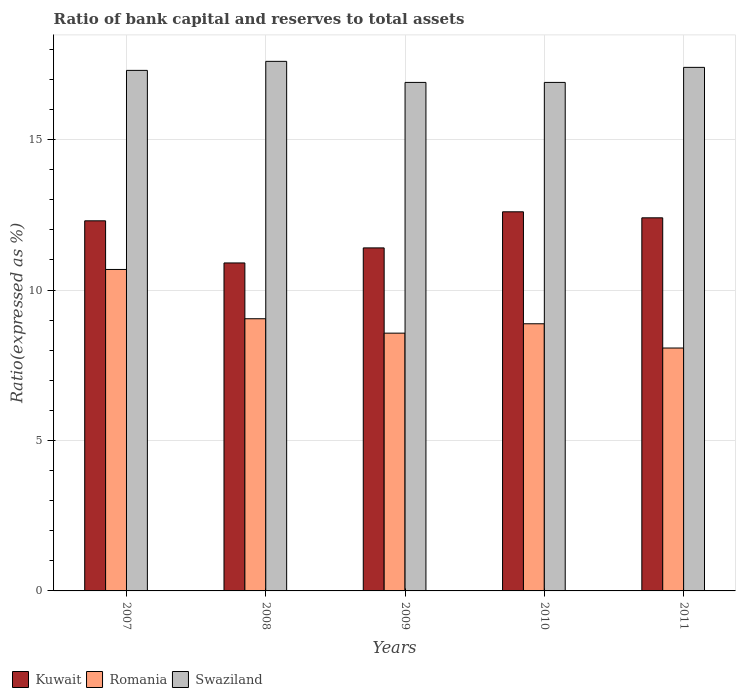Are the number of bars per tick equal to the number of legend labels?
Your answer should be very brief. Yes. Are the number of bars on each tick of the X-axis equal?
Your answer should be very brief. Yes. How many bars are there on the 5th tick from the left?
Provide a short and direct response. 3. How many bars are there on the 3rd tick from the right?
Ensure brevity in your answer.  3. What is the label of the 1st group of bars from the left?
Your answer should be very brief. 2007. What is the total ratio of bank capital and reserves to total assets in Swaziland in the graph?
Keep it short and to the point. 86.1. What is the difference between the ratio of bank capital and reserves to total assets in Swaziland in 2007 and that in 2010?
Make the answer very short. 0.4. What is the average ratio of bank capital and reserves to total assets in Swaziland per year?
Give a very brief answer. 17.22. In the year 2008, what is the difference between the ratio of bank capital and reserves to total assets in Kuwait and ratio of bank capital and reserves to total assets in Romania?
Your response must be concise. 1.85. What is the ratio of the ratio of bank capital and reserves to total assets in Romania in 2008 to that in 2009?
Provide a succinct answer. 1.06. Is the ratio of bank capital and reserves to total assets in Swaziland in 2007 less than that in 2009?
Provide a short and direct response. No. What is the difference between the highest and the second highest ratio of bank capital and reserves to total assets in Swaziland?
Your answer should be very brief. 0.2. What is the difference between the highest and the lowest ratio of bank capital and reserves to total assets in Swaziland?
Offer a terse response. 0.7. In how many years, is the ratio of bank capital and reserves to total assets in Swaziland greater than the average ratio of bank capital and reserves to total assets in Swaziland taken over all years?
Provide a succinct answer. 3. What does the 3rd bar from the left in 2010 represents?
Give a very brief answer. Swaziland. What does the 1st bar from the right in 2008 represents?
Give a very brief answer. Swaziland. Is it the case that in every year, the sum of the ratio of bank capital and reserves to total assets in Kuwait and ratio of bank capital and reserves to total assets in Swaziland is greater than the ratio of bank capital and reserves to total assets in Romania?
Make the answer very short. Yes. How many bars are there?
Your answer should be very brief. 15. Are all the bars in the graph horizontal?
Make the answer very short. No. Does the graph contain any zero values?
Make the answer very short. No. Does the graph contain grids?
Provide a short and direct response. Yes. How many legend labels are there?
Make the answer very short. 3. What is the title of the graph?
Give a very brief answer. Ratio of bank capital and reserves to total assets. What is the label or title of the X-axis?
Your answer should be very brief. Years. What is the label or title of the Y-axis?
Offer a very short reply. Ratio(expressed as %). What is the Ratio(expressed as %) in Romania in 2007?
Your response must be concise. 10.68. What is the Ratio(expressed as %) in Swaziland in 2007?
Give a very brief answer. 17.3. What is the Ratio(expressed as %) in Kuwait in 2008?
Your answer should be compact. 10.9. What is the Ratio(expressed as %) of Romania in 2008?
Your answer should be compact. 9.05. What is the Ratio(expressed as %) in Kuwait in 2009?
Your response must be concise. 11.4. What is the Ratio(expressed as %) of Romania in 2009?
Ensure brevity in your answer.  8.57. What is the Ratio(expressed as %) in Swaziland in 2009?
Your response must be concise. 16.9. What is the Ratio(expressed as %) in Romania in 2010?
Give a very brief answer. 8.88. What is the Ratio(expressed as %) of Swaziland in 2010?
Provide a succinct answer. 16.9. What is the Ratio(expressed as %) of Kuwait in 2011?
Give a very brief answer. 12.4. What is the Ratio(expressed as %) of Romania in 2011?
Provide a short and direct response. 8.07. Across all years, what is the maximum Ratio(expressed as %) in Kuwait?
Give a very brief answer. 12.6. Across all years, what is the maximum Ratio(expressed as %) of Romania?
Your response must be concise. 10.68. Across all years, what is the minimum Ratio(expressed as %) in Kuwait?
Your answer should be very brief. 10.9. Across all years, what is the minimum Ratio(expressed as %) of Romania?
Provide a succinct answer. 8.07. Across all years, what is the minimum Ratio(expressed as %) in Swaziland?
Your answer should be very brief. 16.9. What is the total Ratio(expressed as %) of Kuwait in the graph?
Make the answer very short. 59.6. What is the total Ratio(expressed as %) in Romania in the graph?
Make the answer very short. 45.25. What is the total Ratio(expressed as %) in Swaziland in the graph?
Ensure brevity in your answer.  86.1. What is the difference between the Ratio(expressed as %) in Romania in 2007 and that in 2008?
Provide a short and direct response. 1.64. What is the difference between the Ratio(expressed as %) in Kuwait in 2007 and that in 2009?
Your answer should be compact. 0.9. What is the difference between the Ratio(expressed as %) in Romania in 2007 and that in 2009?
Your answer should be very brief. 2.12. What is the difference between the Ratio(expressed as %) of Swaziland in 2007 and that in 2009?
Make the answer very short. 0.4. What is the difference between the Ratio(expressed as %) in Kuwait in 2007 and that in 2010?
Give a very brief answer. -0.3. What is the difference between the Ratio(expressed as %) in Romania in 2007 and that in 2010?
Give a very brief answer. 1.81. What is the difference between the Ratio(expressed as %) of Romania in 2007 and that in 2011?
Your answer should be very brief. 2.61. What is the difference between the Ratio(expressed as %) in Swaziland in 2007 and that in 2011?
Your answer should be very brief. -0.1. What is the difference between the Ratio(expressed as %) in Romania in 2008 and that in 2009?
Provide a succinct answer. 0.48. What is the difference between the Ratio(expressed as %) of Swaziland in 2008 and that in 2009?
Offer a terse response. 0.7. What is the difference between the Ratio(expressed as %) of Romania in 2008 and that in 2010?
Offer a terse response. 0.17. What is the difference between the Ratio(expressed as %) in Romania in 2008 and that in 2011?
Provide a short and direct response. 0.97. What is the difference between the Ratio(expressed as %) of Kuwait in 2009 and that in 2010?
Keep it short and to the point. -1.2. What is the difference between the Ratio(expressed as %) in Romania in 2009 and that in 2010?
Your response must be concise. -0.31. What is the difference between the Ratio(expressed as %) in Swaziland in 2009 and that in 2010?
Make the answer very short. 0. What is the difference between the Ratio(expressed as %) in Kuwait in 2009 and that in 2011?
Make the answer very short. -1. What is the difference between the Ratio(expressed as %) in Romania in 2009 and that in 2011?
Your answer should be compact. 0.49. What is the difference between the Ratio(expressed as %) in Swaziland in 2009 and that in 2011?
Ensure brevity in your answer.  -0.5. What is the difference between the Ratio(expressed as %) in Romania in 2010 and that in 2011?
Keep it short and to the point. 0.81. What is the difference between the Ratio(expressed as %) in Swaziland in 2010 and that in 2011?
Your answer should be compact. -0.5. What is the difference between the Ratio(expressed as %) of Kuwait in 2007 and the Ratio(expressed as %) of Romania in 2008?
Keep it short and to the point. 3.25. What is the difference between the Ratio(expressed as %) of Kuwait in 2007 and the Ratio(expressed as %) of Swaziland in 2008?
Provide a short and direct response. -5.3. What is the difference between the Ratio(expressed as %) of Romania in 2007 and the Ratio(expressed as %) of Swaziland in 2008?
Ensure brevity in your answer.  -6.92. What is the difference between the Ratio(expressed as %) in Kuwait in 2007 and the Ratio(expressed as %) in Romania in 2009?
Provide a short and direct response. 3.73. What is the difference between the Ratio(expressed as %) in Romania in 2007 and the Ratio(expressed as %) in Swaziland in 2009?
Keep it short and to the point. -6.22. What is the difference between the Ratio(expressed as %) in Kuwait in 2007 and the Ratio(expressed as %) in Romania in 2010?
Your answer should be very brief. 3.42. What is the difference between the Ratio(expressed as %) of Romania in 2007 and the Ratio(expressed as %) of Swaziland in 2010?
Your answer should be compact. -6.22. What is the difference between the Ratio(expressed as %) in Kuwait in 2007 and the Ratio(expressed as %) in Romania in 2011?
Offer a terse response. 4.23. What is the difference between the Ratio(expressed as %) of Kuwait in 2007 and the Ratio(expressed as %) of Swaziland in 2011?
Provide a succinct answer. -5.1. What is the difference between the Ratio(expressed as %) in Romania in 2007 and the Ratio(expressed as %) in Swaziland in 2011?
Offer a very short reply. -6.72. What is the difference between the Ratio(expressed as %) in Kuwait in 2008 and the Ratio(expressed as %) in Romania in 2009?
Offer a terse response. 2.33. What is the difference between the Ratio(expressed as %) of Romania in 2008 and the Ratio(expressed as %) of Swaziland in 2009?
Your answer should be very brief. -7.85. What is the difference between the Ratio(expressed as %) in Kuwait in 2008 and the Ratio(expressed as %) in Romania in 2010?
Offer a very short reply. 2.02. What is the difference between the Ratio(expressed as %) in Kuwait in 2008 and the Ratio(expressed as %) in Swaziland in 2010?
Keep it short and to the point. -6. What is the difference between the Ratio(expressed as %) in Romania in 2008 and the Ratio(expressed as %) in Swaziland in 2010?
Provide a short and direct response. -7.85. What is the difference between the Ratio(expressed as %) in Kuwait in 2008 and the Ratio(expressed as %) in Romania in 2011?
Offer a terse response. 2.83. What is the difference between the Ratio(expressed as %) in Romania in 2008 and the Ratio(expressed as %) in Swaziland in 2011?
Offer a very short reply. -8.35. What is the difference between the Ratio(expressed as %) of Kuwait in 2009 and the Ratio(expressed as %) of Romania in 2010?
Your answer should be very brief. 2.52. What is the difference between the Ratio(expressed as %) in Kuwait in 2009 and the Ratio(expressed as %) in Swaziland in 2010?
Offer a terse response. -5.5. What is the difference between the Ratio(expressed as %) of Romania in 2009 and the Ratio(expressed as %) of Swaziland in 2010?
Your answer should be very brief. -8.33. What is the difference between the Ratio(expressed as %) of Kuwait in 2009 and the Ratio(expressed as %) of Romania in 2011?
Offer a terse response. 3.33. What is the difference between the Ratio(expressed as %) of Kuwait in 2009 and the Ratio(expressed as %) of Swaziland in 2011?
Your answer should be very brief. -6. What is the difference between the Ratio(expressed as %) of Romania in 2009 and the Ratio(expressed as %) of Swaziland in 2011?
Provide a short and direct response. -8.83. What is the difference between the Ratio(expressed as %) in Kuwait in 2010 and the Ratio(expressed as %) in Romania in 2011?
Your answer should be very brief. 4.53. What is the difference between the Ratio(expressed as %) in Romania in 2010 and the Ratio(expressed as %) in Swaziland in 2011?
Make the answer very short. -8.52. What is the average Ratio(expressed as %) of Kuwait per year?
Your answer should be very brief. 11.92. What is the average Ratio(expressed as %) of Romania per year?
Offer a terse response. 9.05. What is the average Ratio(expressed as %) of Swaziland per year?
Your response must be concise. 17.22. In the year 2007, what is the difference between the Ratio(expressed as %) of Kuwait and Ratio(expressed as %) of Romania?
Your answer should be compact. 1.62. In the year 2007, what is the difference between the Ratio(expressed as %) in Romania and Ratio(expressed as %) in Swaziland?
Make the answer very short. -6.62. In the year 2008, what is the difference between the Ratio(expressed as %) in Kuwait and Ratio(expressed as %) in Romania?
Your answer should be very brief. 1.85. In the year 2008, what is the difference between the Ratio(expressed as %) in Kuwait and Ratio(expressed as %) in Swaziland?
Your answer should be very brief. -6.7. In the year 2008, what is the difference between the Ratio(expressed as %) of Romania and Ratio(expressed as %) of Swaziland?
Give a very brief answer. -8.55. In the year 2009, what is the difference between the Ratio(expressed as %) of Kuwait and Ratio(expressed as %) of Romania?
Ensure brevity in your answer.  2.83. In the year 2009, what is the difference between the Ratio(expressed as %) of Romania and Ratio(expressed as %) of Swaziland?
Offer a terse response. -8.33. In the year 2010, what is the difference between the Ratio(expressed as %) of Kuwait and Ratio(expressed as %) of Romania?
Your answer should be compact. 3.72. In the year 2010, what is the difference between the Ratio(expressed as %) in Kuwait and Ratio(expressed as %) in Swaziland?
Keep it short and to the point. -4.3. In the year 2010, what is the difference between the Ratio(expressed as %) of Romania and Ratio(expressed as %) of Swaziland?
Offer a very short reply. -8.02. In the year 2011, what is the difference between the Ratio(expressed as %) of Kuwait and Ratio(expressed as %) of Romania?
Offer a very short reply. 4.33. In the year 2011, what is the difference between the Ratio(expressed as %) of Kuwait and Ratio(expressed as %) of Swaziland?
Offer a terse response. -5. In the year 2011, what is the difference between the Ratio(expressed as %) of Romania and Ratio(expressed as %) of Swaziland?
Offer a terse response. -9.33. What is the ratio of the Ratio(expressed as %) in Kuwait in 2007 to that in 2008?
Your answer should be compact. 1.13. What is the ratio of the Ratio(expressed as %) in Romania in 2007 to that in 2008?
Provide a short and direct response. 1.18. What is the ratio of the Ratio(expressed as %) of Kuwait in 2007 to that in 2009?
Provide a short and direct response. 1.08. What is the ratio of the Ratio(expressed as %) in Romania in 2007 to that in 2009?
Offer a terse response. 1.25. What is the ratio of the Ratio(expressed as %) in Swaziland in 2007 to that in 2009?
Provide a succinct answer. 1.02. What is the ratio of the Ratio(expressed as %) of Kuwait in 2007 to that in 2010?
Provide a succinct answer. 0.98. What is the ratio of the Ratio(expressed as %) in Romania in 2007 to that in 2010?
Your response must be concise. 1.2. What is the ratio of the Ratio(expressed as %) of Swaziland in 2007 to that in 2010?
Offer a very short reply. 1.02. What is the ratio of the Ratio(expressed as %) of Kuwait in 2007 to that in 2011?
Provide a short and direct response. 0.99. What is the ratio of the Ratio(expressed as %) in Romania in 2007 to that in 2011?
Offer a terse response. 1.32. What is the ratio of the Ratio(expressed as %) in Swaziland in 2007 to that in 2011?
Your answer should be very brief. 0.99. What is the ratio of the Ratio(expressed as %) in Kuwait in 2008 to that in 2009?
Offer a terse response. 0.96. What is the ratio of the Ratio(expressed as %) in Romania in 2008 to that in 2009?
Your response must be concise. 1.06. What is the ratio of the Ratio(expressed as %) of Swaziland in 2008 to that in 2009?
Your response must be concise. 1.04. What is the ratio of the Ratio(expressed as %) of Kuwait in 2008 to that in 2010?
Ensure brevity in your answer.  0.87. What is the ratio of the Ratio(expressed as %) of Romania in 2008 to that in 2010?
Your answer should be very brief. 1.02. What is the ratio of the Ratio(expressed as %) of Swaziland in 2008 to that in 2010?
Ensure brevity in your answer.  1.04. What is the ratio of the Ratio(expressed as %) of Kuwait in 2008 to that in 2011?
Keep it short and to the point. 0.88. What is the ratio of the Ratio(expressed as %) of Romania in 2008 to that in 2011?
Give a very brief answer. 1.12. What is the ratio of the Ratio(expressed as %) in Swaziland in 2008 to that in 2011?
Your answer should be very brief. 1.01. What is the ratio of the Ratio(expressed as %) of Kuwait in 2009 to that in 2010?
Keep it short and to the point. 0.9. What is the ratio of the Ratio(expressed as %) in Romania in 2009 to that in 2010?
Keep it short and to the point. 0.96. What is the ratio of the Ratio(expressed as %) in Swaziland in 2009 to that in 2010?
Provide a short and direct response. 1. What is the ratio of the Ratio(expressed as %) in Kuwait in 2009 to that in 2011?
Provide a succinct answer. 0.92. What is the ratio of the Ratio(expressed as %) of Romania in 2009 to that in 2011?
Provide a succinct answer. 1.06. What is the ratio of the Ratio(expressed as %) of Swaziland in 2009 to that in 2011?
Keep it short and to the point. 0.97. What is the ratio of the Ratio(expressed as %) of Kuwait in 2010 to that in 2011?
Keep it short and to the point. 1.02. What is the ratio of the Ratio(expressed as %) of Romania in 2010 to that in 2011?
Your answer should be compact. 1.1. What is the ratio of the Ratio(expressed as %) of Swaziland in 2010 to that in 2011?
Ensure brevity in your answer.  0.97. What is the difference between the highest and the second highest Ratio(expressed as %) in Romania?
Make the answer very short. 1.64. What is the difference between the highest and the lowest Ratio(expressed as %) of Kuwait?
Provide a short and direct response. 1.7. What is the difference between the highest and the lowest Ratio(expressed as %) of Romania?
Your answer should be compact. 2.61. What is the difference between the highest and the lowest Ratio(expressed as %) of Swaziland?
Offer a very short reply. 0.7. 